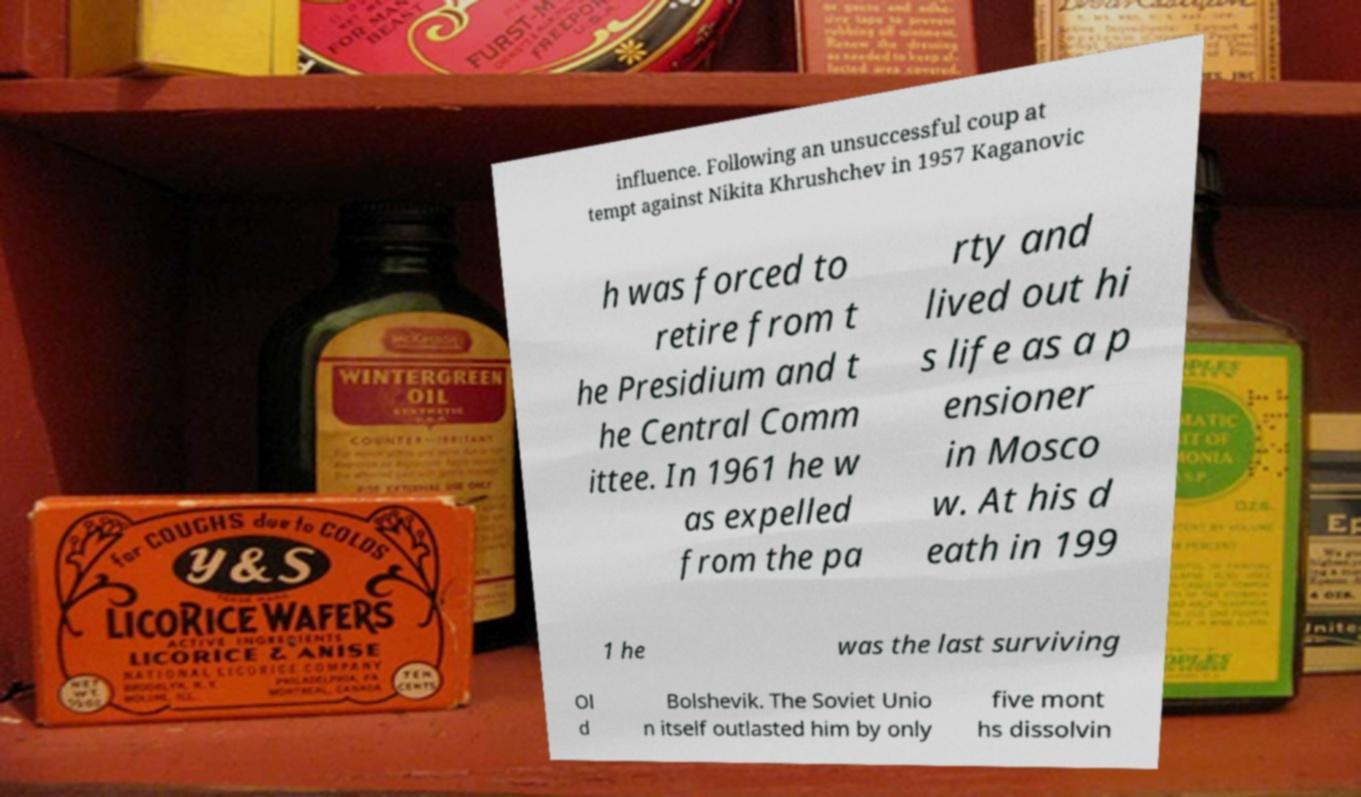Could you assist in decoding the text presented in this image and type it out clearly? influence. Following an unsuccessful coup at tempt against Nikita Khrushchev in 1957 Kaganovic h was forced to retire from t he Presidium and t he Central Comm ittee. In 1961 he w as expelled from the pa rty and lived out hi s life as a p ensioner in Mosco w. At his d eath in 199 1 he was the last surviving Ol d Bolshevik. The Soviet Unio n itself outlasted him by only five mont hs dissolvin 